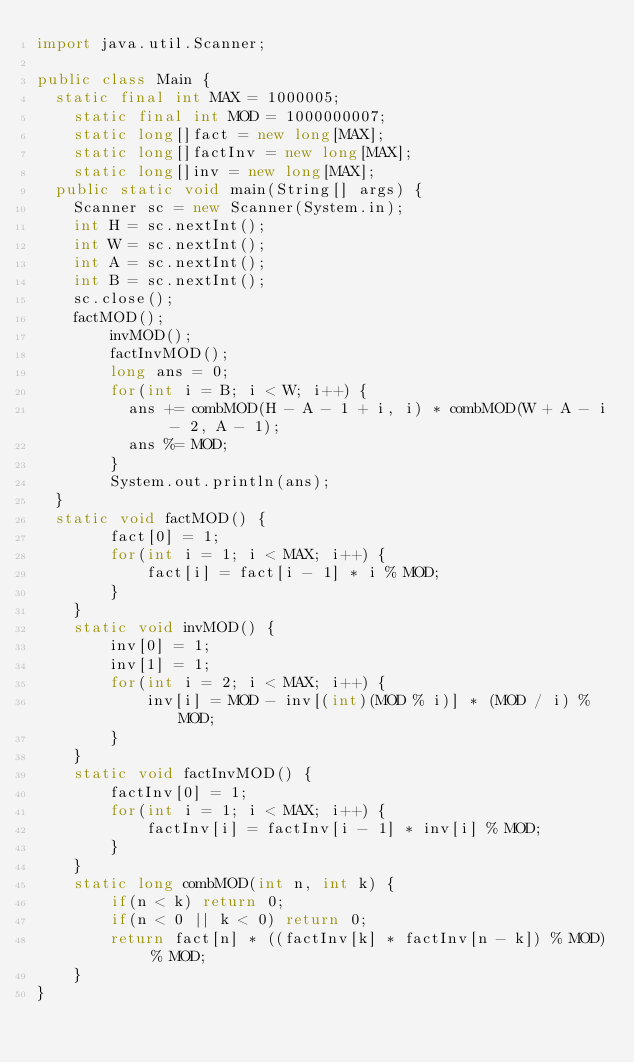<code> <loc_0><loc_0><loc_500><loc_500><_Java_>import java.util.Scanner;

public class Main {
	static final int MAX = 1000005;
    static final int MOD = 1000000007;
    static long[]fact = new long[MAX];
    static long[]factInv = new long[MAX];
    static long[]inv = new long[MAX];
	public static void main(String[] args) {
		Scanner sc = new Scanner(System.in);
		int H = sc.nextInt();
		int W = sc.nextInt();
		int A = sc.nextInt();
		int B = sc.nextInt();
		sc.close();
		factMOD();
        invMOD();
        factInvMOD();
        long ans = 0;
        for(int i = B; i < W; i++) {
        	ans += combMOD(H - A - 1 + i, i) * combMOD(W + A - i - 2, A - 1);
        	ans %= MOD;
        }
        System.out.println(ans);
	}
	static void factMOD() {
        fact[0] = 1;
        for(int i = 1; i < MAX; i++) {
            fact[i] = fact[i - 1] * i % MOD;
        }
    }
    static void invMOD() {
        inv[0] = 1;
        inv[1] = 1;
        for(int i = 2; i < MAX; i++) {
            inv[i] = MOD - inv[(int)(MOD % i)] * (MOD / i) % MOD;
        }
    }
    static void factInvMOD() {
        factInv[0] = 1;
        for(int i = 1; i < MAX; i++) {
            factInv[i] = factInv[i - 1] * inv[i] % MOD;
        }
    }
    static long combMOD(int n, int k) {
        if(n < k) return 0;
        if(n < 0 || k < 0) return 0;
        return fact[n] * ((factInv[k] * factInv[n - k]) % MOD) % MOD;
    }
}</code> 